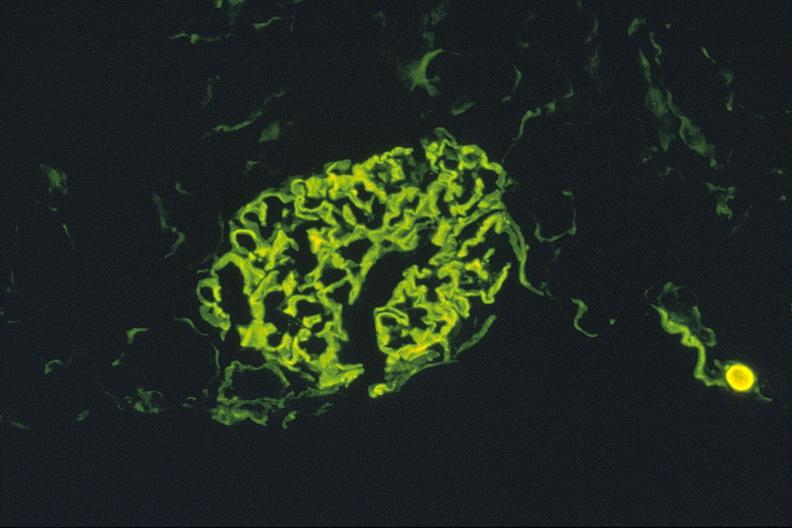s urinary present?
Answer the question using a single word or phrase. Yes 